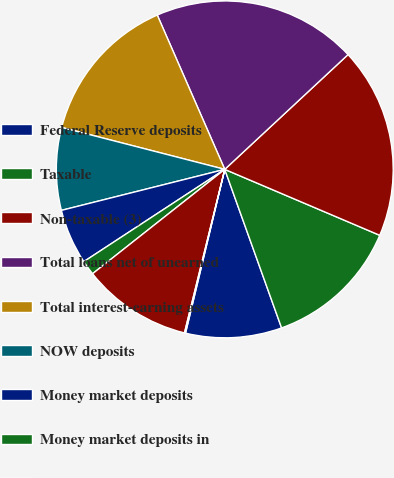<chart> <loc_0><loc_0><loc_500><loc_500><pie_chart><fcel>Federal Reserve deposits<fcel>Taxable<fcel>Non-taxable (3)<fcel>Total loans net of unearned<fcel>Total interest-earning assets<fcel>NOW deposits<fcel>Money market deposits<fcel>Money market deposits in<fcel>Time deposits<fcel>Sweep deposits in foreign<nl><fcel>9.22%<fcel>13.12%<fcel>18.33%<fcel>19.63%<fcel>14.43%<fcel>7.92%<fcel>5.31%<fcel>1.41%<fcel>10.52%<fcel>0.1%<nl></chart> 